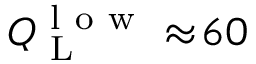Convert formula to latex. <formula><loc_0><loc_0><loc_500><loc_500>Q _ { L } ^ { l o w } \approx \, 6 0</formula> 